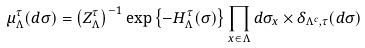<formula> <loc_0><loc_0><loc_500><loc_500>\mu _ { \Lambda } ^ { \tau } ( d \sigma ) = \left ( Z _ { \Lambda } ^ { \tau } \right ) ^ { - 1 } \exp \left \{ - H _ { \Lambda } ^ { \tau } ( \sigma ) \right \} \prod _ { x \in \Lambda } d \sigma _ { x } \times \delta _ { \Lambda ^ { c } , \tau } ( d \sigma )</formula> 